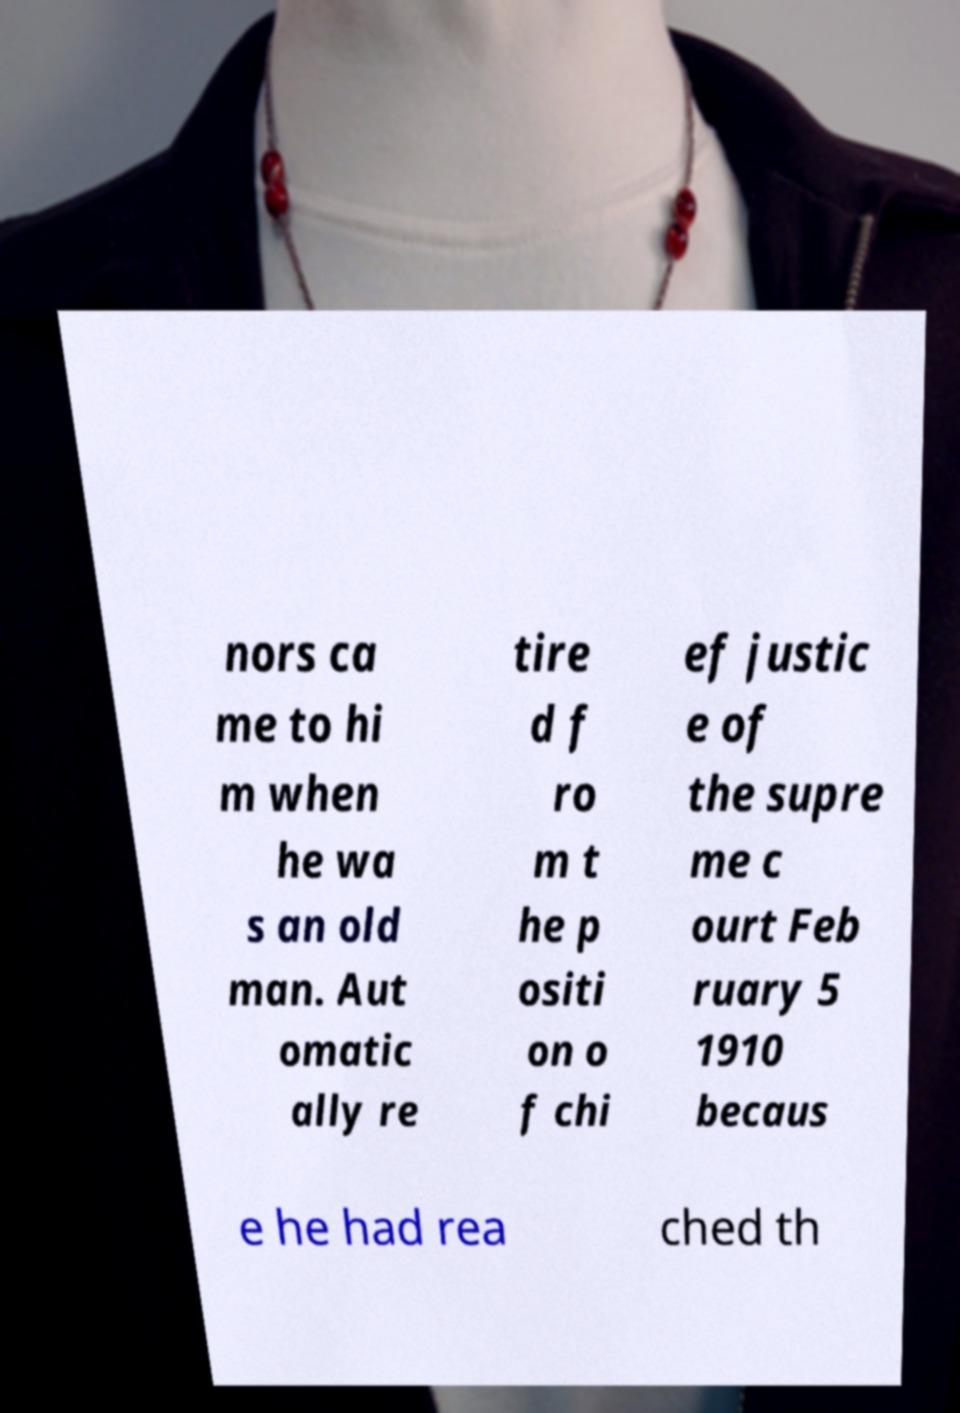I need the written content from this picture converted into text. Can you do that? nors ca me to hi m when he wa s an old man. Aut omatic ally re tire d f ro m t he p ositi on o f chi ef justic e of the supre me c ourt Feb ruary 5 1910 becaus e he had rea ched th 